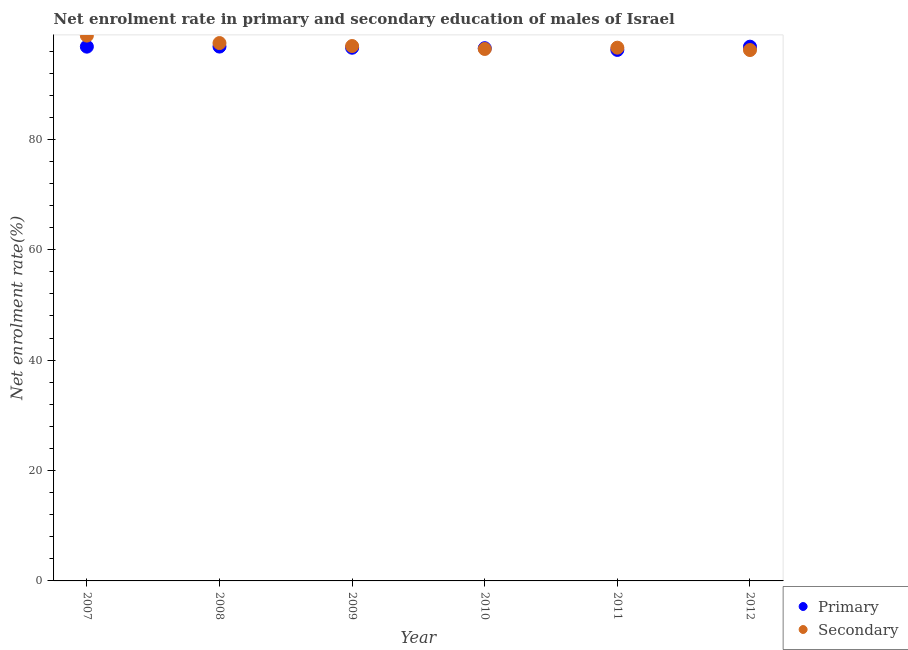What is the enrollment rate in secondary education in 2009?
Your answer should be very brief. 96.91. Across all years, what is the maximum enrollment rate in primary education?
Give a very brief answer. 96.81. Across all years, what is the minimum enrollment rate in secondary education?
Offer a very short reply. 96.18. In which year was the enrollment rate in secondary education maximum?
Keep it short and to the point. 2007. In which year was the enrollment rate in secondary education minimum?
Keep it short and to the point. 2012. What is the total enrollment rate in secondary education in the graph?
Provide a succinct answer. 582.34. What is the difference between the enrollment rate in primary education in 2008 and that in 2009?
Provide a succinct answer. 0.21. What is the difference between the enrollment rate in primary education in 2007 and the enrollment rate in secondary education in 2009?
Your response must be concise. -0.11. What is the average enrollment rate in secondary education per year?
Make the answer very short. 97.06. In the year 2012, what is the difference between the enrollment rate in primary education and enrollment rate in secondary education?
Provide a short and direct response. 0.61. In how many years, is the enrollment rate in secondary education greater than 60 %?
Ensure brevity in your answer.  6. What is the ratio of the enrollment rate in primary education in 2008 to that in 2009?
Keep it short and to the point. 1. Is the difference between the enrollment rate in secondary education in 2007 and 2010 greater than the difference between the enrollment rate in primary education in 2007 and 2010?
Provide a succinct answer. Yes. What is the difference between the highest and the second highest enrollment rate in primary education?
Keep it short and to the point. 0.01. What is the difference between the highest and the lowest enrollment rate in primary education?
Provide a short and direct response. 0.6. In how many years, is the enrollment rate in primary education greater than the average enrollment rate in primary education taken over all years?
Offer a terse response. 3. Is the enrollment rate in secondary education strictly greater than the enrollment rate in primary education over the years?
Your answer should be compact. No. Is the enrollment rate in secondary education strictly less than the enrollment rate in primary education over the years?
Your answer should be very brief. No. How many dotlines are there?
Your answer should be very brief. 2. How many years are there in the graph?
Make the answer very short. 6. Does the graph contain any zero values?
Keep it short and to the point. No. Does the graph contain grids?
Your response must be concise. No. How many legend labels are there?
Keep it short and to the point. 2. What is the title of the graph?
Ensure brevity in your answer.  Net enrolment rate in primary and secondary education of males of Israel. Does "Current education expenditure" appear as one of the legend labels in the graph?
Ensure brevity in your answer.  No. What is the label or title of the X-axis?
Your answer should be compact. Year. What is the label or title of the Y-axis?
Offer a terse response. Net enrolment rate(%). What is the Net enrolment rate(%) of Primary in 2007?
Provide a short and direct response. 96.8. What is the Net enrolment rate(%) in Secondary in 2007?
Provide a succinct answer. 98.8. What is the Net enrolment rate(%) of Primary in 2008?
Make the answer very short. 96.81. What is the Net enrolment rate(%) of Secondary in 2008?
Give a very brief answer. 97.45. What is the Net enrolment rate(%) in Primary in 2009?
Make the answer very short. 96.6. What is the Net enrolment rate(%) in Secondary in 2009?
Offer a terse response. 96.91. What is the Net enrolment rate(%) of Primary in 2010?
Offer a very short reply. 96.52. What is the Net enrolment rate(%) of Secondary in 2010?
Offer a terse response. 96.38. What is the Net enrolment rate(%) of Primary in 2011?
Offer a very short reply. 96.21. What is the Net enrolment rate(%) in Secondary in 2011?
Make the answer very short. 96.61. What is the Net enrolment rate(%) of Primary in 2012?
Offer a very short reply. 96.8. What is the Net enrolment rate(%) in Secondary in 2012?
Make the answer very short. 96.18. Across all years, what is the maximum Net enrolment rate(%) in Primary?
Your response must be concise. 96.81. Across all years, what is the maximum Net enrolment rate(%) in Secondary?
Give a very brief answer. 98.8. Across all years, what is the minimum Net enrolment rate(%) of Primary?
Provide a short and direct response. 96.21. Across all years, what is the minimum Net enrolment rate(%) in Secondary?
Ensure brevity in your answer.  96.18. What is the total Net enrolment rate(%) in Primary in the graph?
Make the answer very short. 579.74. What is the total Net enrolment rate(%) in Secondary in the graph?
Provide a short and direct response. 582.34. What is the difference between the Net enrolment rate(%) in Primary in 2007 and that in 2008?
Offer a terse response. -0.01. What is the difference between the Net enrolment rate(%) in Secondary in 2007 and that in 2008?
Offer a terse response. 1.35. What is the difference between the Net enrolment rate(%) in Primary in 2007 and that in 2009?
Make the answer very short. 0.2. What is the difference between the Net enrolment rate(%) of Secondary in 2007 and that in 2009?
Provide a succinct answer. 1.89. What is the difference between the Net enrolment rate(%) of Primary in 2007 and that in 2010?
Your answer should be very brief. 0.28. What is the difference between the Net enrolment rate(%) of Secondary in 2007 and that in 2010?
Provide a succinct answer. 2.42. What is the difference between the Net enrolment rate(%) in Primary in 2007 and that in 2011?
Ensure brevity in your answer.  0.59. What is the difference between the Net enrolment rate(%) of Secondary in 2007 and that in 2011?
Ensure brevity in your answer.  2.19. What is the difference between the Net enrolment rate(%) of Primary in 2007 and that in 2012?
Ensure brevity in your answer.  0. What is the difference between the Net enrolment rate(%) in Secondary in 2007 and that in 2012?
Ensure brevity in your answer.  2.62. What is the difference between the Net enrolment rate(%) of Primary in 2008 and that in 2009?
Your response must be concise. 0.21. What is the difference between the Net enrolment rate(%) in Secondary in 2008 and that in 2009?
Offer a very short reply. 0.54. What is the difference between the Net enrolment rate(%) of Primary in 2008 and that in 2010?
Offer a very short reply. 0.29. What is the difference between the Net enrolment rate(%) of Secondary in 2008 and that in 2010?
Make the answer very short. 1.07. What is the difference between the Net enrolment rate(%) in Primary in 2008 and that in 2011?
Your response must be concise. 0.6. What is the difference between the Net enrolment rate(%) in Secondary in 2008 and that in 2011?
Provide a succinct answer. 0.84. What is the difference between the Net enrolment rate(%) of Primary in 2008 and that in 2012?
Your answer should be very brief. 0.02. What is the difference between the Net enrolment rate(%) in Secondary in 2008 and that in 2012?
Give a very brief answer. 1.27. What is the difference between the Net enrolment rate(%) in Primary in 2009 and that in 2010?
Ensure brevity in your answer.  0.08. What is the difference between the Net enrolment rate(%) in Secondary in 2009 and that in 2010?
Your response must be concise. 0.53. What is the difference between the Net enrolment rate(%) in Primary in 2009 and that in 2011?
Make the answer very short. 0.39. What is the difference between the Net enrolment rate(%) of Secondary in 2009 and that in 2011?
Ensure brevity in your answer.  0.3. What is the difference between the Net enrolment rate(%) in Primary in 2009 and that in 2012?
Ensure brevity in your answer.  -0.19. What is the difference between the Net enrolment rate(%) of Secondary in 2009 and that in 2012?
Your response must be concise. 0.73. What is the difference between the Net enrolment rate(%) of Primary in 2010 and that in 2011?
Your answer should be very brief. 0.31. What is the difference between the Net enrolment rate(%) in Secondary in 2010 and that in 2011?
Your answer should be compact. -0.23. What is the difference between the Net enrolment rate(%) of Primary in 2010 and that in 2012?
Ensure brevity in your answer.  -0.27. What is the difference between the Net enrolment rate(%) of Secondary in 2010 and that in 2012?
Ensure brevity in your answer.  0.2. What is the difference between the Net enrolment rate(%) of Primary in 2011 and that in 2012?
Make the answer very short. -0.59. What is the difference between the Net enrolment rate(%) in Secondary in 2011 and that in 2012?
Ensure brevity in your answer.  0.43. What is the difference between the Net enrolment rate(%) in Primary in 2007 and the Net enrolment rate(%) in Secondary in 2008?
Give a very brief answer. -0.65. What is the difference between the Net enrolment rate(%) of Primary in 2007 and the Net enrolment rate(%) of Secondary in 2009?
Give a very brief answer. -0.11. What is the difference between the Net enrolment rate(%) of Primary in 2007 and the Net enrolment rate(%) of Secondary in 2010?
Give a very brief answer. 0.42. What is the difference between the Net enrolment rate(%) of Primary in 2007 and the Net enrolment rate(%) of Secondary in 2011?
Provide a succinct answer. 0.18. What is the difference between the Net enrolment rate(%) of Primary in 2007 and the Net enrolment rate(%) of Secondary in 2012?
Your response must be concise. 0.61. What is the difference between the Net enrolment rate(%) of Primary in 2008 and the Net enrolment rate(%) of Secondary in 2009?
Keep it short and to the point. -0.1. What is the difference between the Net enrolment rate(%) of Primary in 2008 and the Net enrolment rate(%) of Secondary in 2010?
Ensure brevity in your answer.  0.43. What is the difference between the Net enrolment rate(%) in Primary in 2008 and the Net enrolment rate(%) in Secondary in 2011?
Offer a very short reply. 0.2. What is the difference between the Net enrolment rate(%) in Primary in 2008 and the Net enrolment rate(%) in Secondary in 2012?
Your answer should be very brief. 0.63. What is the difference between the Net enrolment rate(%) in Primary in 2009 and the Net enrolment rate(%) in Secondary in 2010?
Give a very brief answer. 0.22. What is the difference between the Net enrolment rate(%) in Primary in 2009 and the Net enrolment rate(%) in Secondary in 2011?
Provide a succinct answer. -0.01. What is the difference between the Net enrolment rate(%) in Primary in 2009 and the Net enrolment rate(%) in Secondary in 2012?
Keep it short and to the point. 0.42. What is the difference between the Net enrolment rate(%) of Primary in 2010 and the Net enrolment rate(%) of Secondary in 2011?
Give a very brief answer. -0.09. What is the difference between the Net enrolment rate(%) in Primary in 2010 and the Net enrolment rate(%) in Secondary in 2012?
Provide a short and direct response. 0.34. What is the difference between the Net enrolment rate(%) in Primary in 2011 and the Net enrolment rate(%) in Secondary in 2012?
Provide a short and direct response. 0.02. What is the average Net enrolment rate(%) in Primary per year?
Provide a short and direct response. 96.62. What is the average Net enrolment rate(%) in Secondary per year?
Your response must be concise. 97.06. In the year 2007, what is the difference between the Net enrolment rate(%) in Primary and Net enrolment rate(%) in Secondary?
Offer a terse response. -2. In the year 2008, what is the difference between the Net enrolment rate(%) in Primary and Net enrolment rate(%) in Secondary?
Your answer should be compact. -0.64. In the year 2009, what is the difference between the Net enrolment rate(%) in Primary and Net enrolment rate(%) in Secondary?
Your answer should be very brief. -0.31. In the year 2010, what is the difference between the Net enrolment rate(%) of Primary and Net enrolment rate(%) of Secondary?
Offer a terse response. 0.14. In the year 2011, what is the difference between the Net enrolment rate(%) of Primary and Net enrolment rate(%) of Secondary?
Keep it short and to the point. -0.41. In the year 2012, what is the difference between the Net enrolment rate(%) of Primary and Net enrolment rate(%) of Secondary?
Make the answer very short. 0.61. What is the ratio of the Net enrolment rate(%) in Secondary in 2007 to that in 2008?
Offer a terse response. 1.01. What is the ratio of the Net enrolment rate(%) of Secondary in 2007 to that in 2009?
Provide a succinct answer. 1.02. What is the ratio of the Net enrolment rate(%) in Secondary in 2007 to that in 2010?
Your response must be concise. 1.03. What is the ratio of the Net enrolment rate(%) of Primary in 2007 to that in 2011?
Your answer should be compact. 1.01. What is the ratio of the Net enrolment rate(%) in Secondary in 2007 to that in 2011?
Provide a succinct answer. 1.02. What is the ratio of the Net enrolment rate(%) of Secondary in 2007 to that in 2012?
Your answer should be compact. 1.03. What is the ratio of the Net enrolment rate(%) in Secondary in 2008 to that in 2009?
Ensure brevity in your answer.  1.01. What is the ratio of the Net enrolment rate(%) in Secondary in 2008 to that in 2010?
Provide a short and direct response. 1.01. What is the ratio of the Net enrolment rate(%) in Secondary in 2008 to that in 2011?
Your answer should be compact. 1.01. What is the ratio of the Net enrolment rate(%) of Secondary in 2008 to that in 2012?
Your answer should be very brief. 1.01. What is the ratio of the Net enrolment rate(%) in Primary in 2009 to that in 2010?
Give a very brief answer. 1. What is the ratio of the Net enrolment rate(%) in Secondary in 2009 to that in 2010?
Give a very brief answer. 1.01. What is the ratio of the Net enrolment rate(%) in Primary in 2009 to that in 2011?
Provide a short and direct response. 1. What is the ratio of the Net enrolment rate(%) of Secondary in 2009 to that in 2012?
Give a very brief answer. 1.01. What is the ratio of the Net enrolment rate(%) in Secondary in 2010 to that in 2011?
Ensure brevity in your answer.  1. What is the difference between the highest and the second highest Net enrolment rate(%) in Primary?
Your answer should be very brief. 0.01. What is the difference between the highest and the second highest Net enrolment rate(%) of Secondary?
Offer a terse response. 1.35. What is the difference between the highest and the lowest Net enrolment rate(%) in Primary?
Provide a short and direct response. 0.6. What is the difference between the highest and the lowest Net enrolment rate(%) in Secondary?
Make the answer very short. 2.62. 